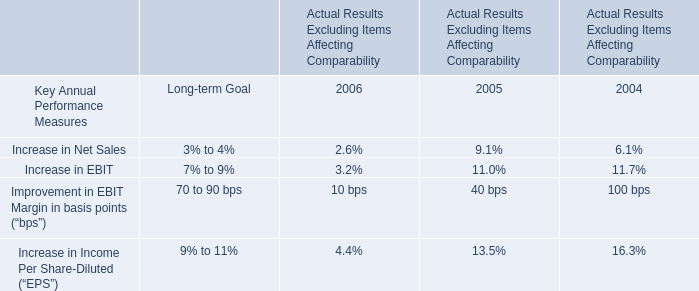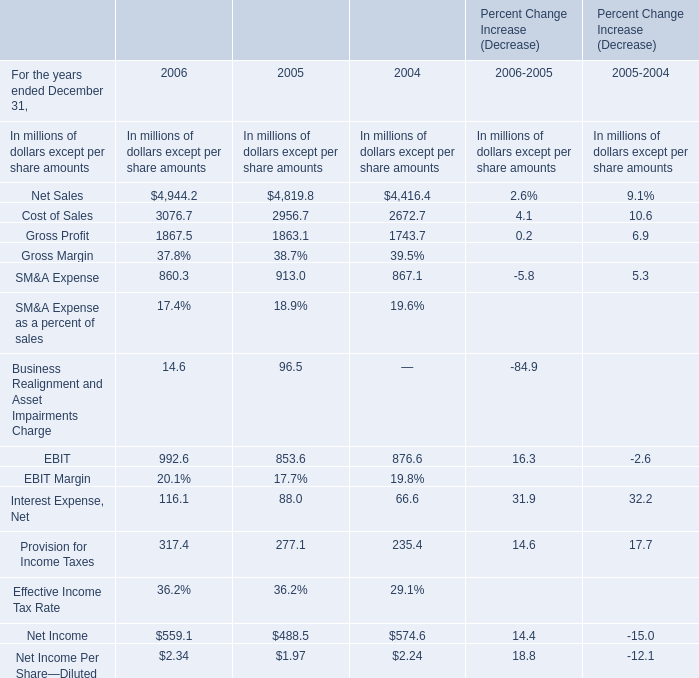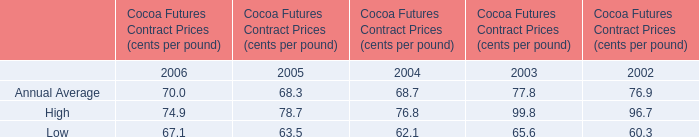What was the average value of the EBIT in the years where Net Sales is positive? (in million) 
Computations: (((992.6 + 853.6) + 876.6) / 3)
Answer: 907.6. 